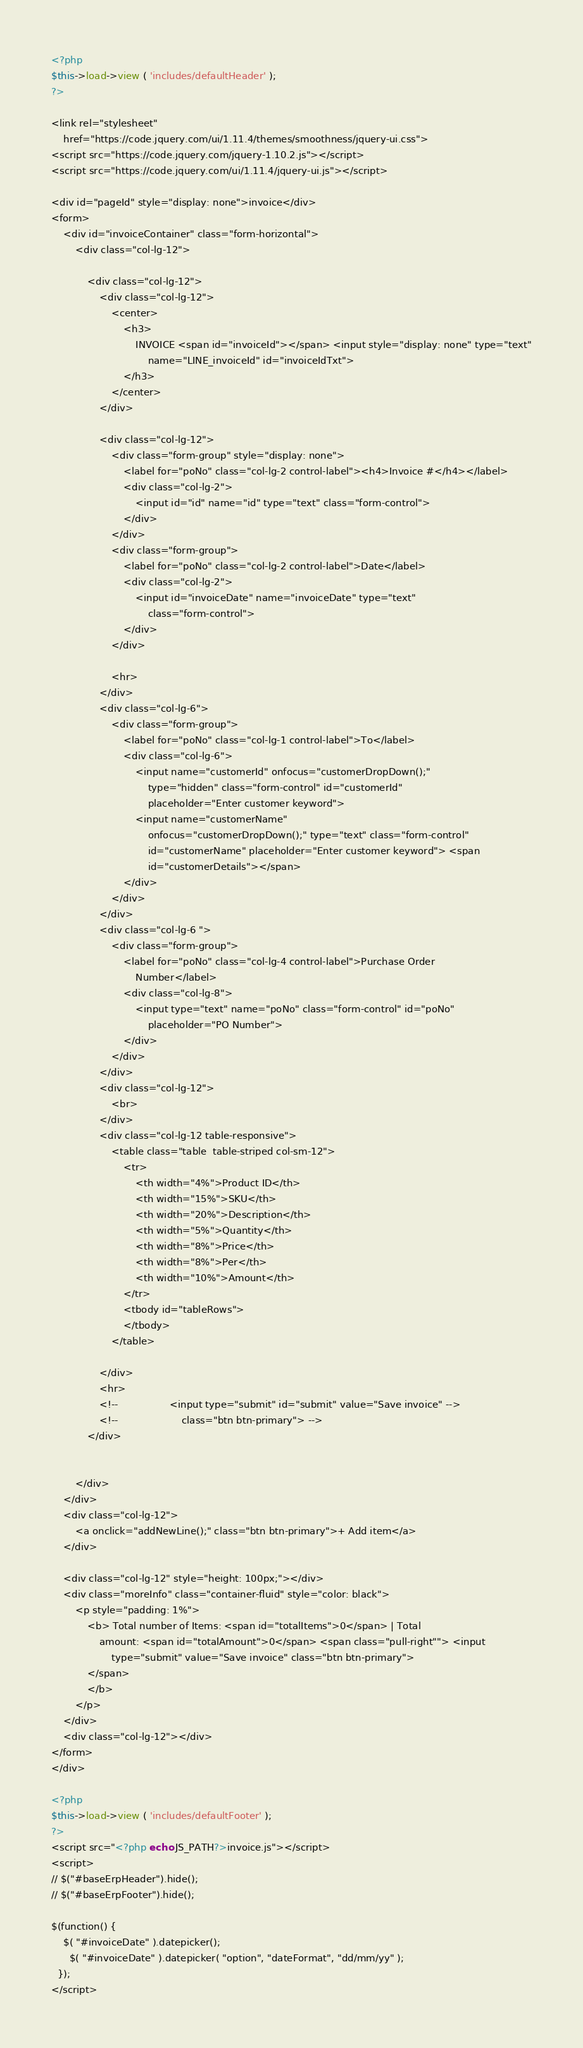Convert code to text. <code><loc_0><loc_0><loc_500><loc_500><_PHP_><?php
$this->load->view ( 'includes/defaultHeader' );
?>

<link rel="stylesheet"
	href="https://code.jquery.com/ui/1.11.4/themes/smoothness/jquery-ui.css">
<script src="https://code.jquery.com/jquery-1.10.2.js"></script>
<script src="https://code.jquery.com/ui/1.11.4/jquery-ui.js"></script>

<div id="pageId" style="display: none">invoice</div>
<form>
	<div id="invoiceContainer" class="form-horizontal">
		<div class="col-lg-12">

			<div class="col-lg-12">
				<div class="col-lg-12">
					<center>
						<h3>
							INVOICE <span id="invoiceId"></span> <input style="display: none" type="text"
								name="LINE_invoiceId" id="invoiceIdTxt">
						</h3>
					</center>
				</div>

				<div class="col-lg-12">
					<div class="form-group" style="display: none">
						<label for="poNo" class="col-lg-2 control-label"><h4>Invoice #</h4></label>
						<div class="col-lg-2">
							<input id="id" name="id" type="text" class="form-control">
						</div>
					</div>
					<div class="form-group">
						<label for="poNo" class="col-lg-2 control-label">Date</label>
						<div class="col-lg-2">
							<input id="invoiceDate" name="invoiceDate" type="text"
								class="form-control">
						</div>
					</div>

					<hr>
				</div>
				<div class="col-lg-6">
					<div class="form-group">
						<label for="poNo" class="col-lg-1 control-label">To</label>
						<div class="col-lg-6">
							<input name="customerId" onfocus="customerDropDown();"
								type="hidden" class="form-control" id="customerId"
								placeholder="Enter customer keyword"> 
							<input name="customerName"
								onfocus="customerDropDown();" type="text" class="form-control"
								id="customerName" placeholder="Enter customer keyword"> <span
								id="customerDetails"></span>
						</div>
					</div>
				</div>
				<div class="col-lg-6 ">
					<div class="form-group">
						<label for="poNo" class="col-lg-4 control-label">Purchase Order
							Number</label>
						<div class="col-lg-8">
							<input type="text" name="poNo" class="form-control" id="poNo"
								placeholder="PO Number">
						</div>
					</div>
				</div>
				<div class="col-lg-12">
					<br>
				</div>
				<div class="col-lg-12 table-responsive">
					<table class="table  table-striped col-sm-12">
						<tr>
							<th width="4%">Product ID</th>
							<th width="15%">SKU</th>
							<th width="20%">Description</th>
							<th width="5%">Quantity</th>
							<th width="8%">Price</th>
							<th width="8%">Per</th>
							<th width="10%">Amount</th>
						</tr>
						<tbody id="tableRows">
						</tbody>
					</table>

				</div>
				<hr>
				<!-- 				<input type="submit" id="submit" value="Save invoice" -->
				<!-- 					class="btn btn-primary"> -->
			</div>


		</div>
	</div>
	<div class="col-lg-12">
		<a onclick="addNewLine();" class="btn btn-primary">+ Add item</a>
	</div>

	<div class="col-lg-12" style="height: 100px;"></div>
	<div class="moreInfo" class="container-fluid" style="color: black">
		<p style="padding: 1%">
			<b> Total number of Items: <span id="totalItems">0</span> | Total
				amount: <span id="totalAmount">0</span> <span class="pull-right""> <input
					type="submit" value="Save invoice" class="btn btn-primary">
			</span>
			</b>
		</p>
	</div>
	<div class="col-lg-12"></div>
</form>
</div>

<?php
$this->load->view ( 'includes/defaultFooter' );
?>
<script src="<?php echo JS_PATH?>invoice.js"></script>
<script>
// $("#baseErpHeader").hide();
// $("#baseErpFooter").hide();

$(function() {
    $( "#invoiceDate" ).datepicker();
      $( "#invoiceDate" ).datepicker( "option", "dateFormat", "dd/mm/yy" );
  });
</script>
</code> 